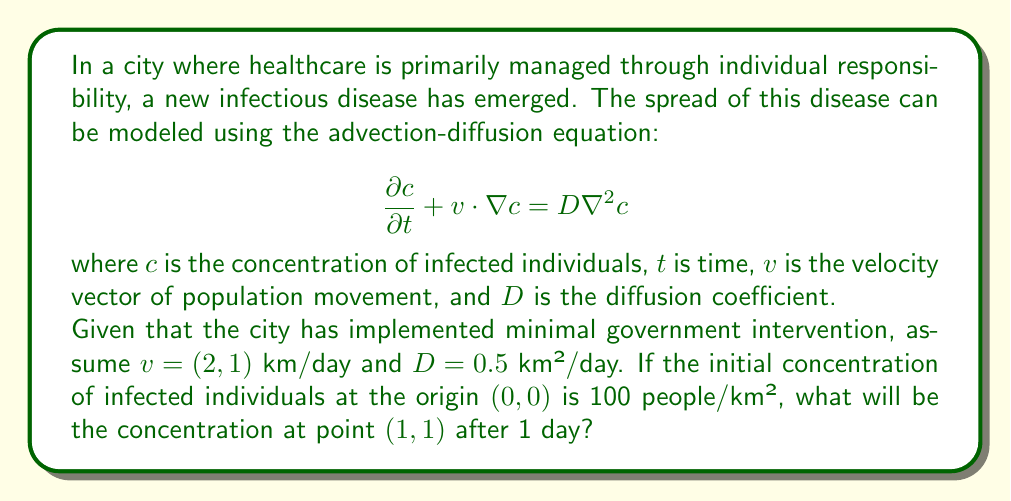Show me your answer to this math problem. To solve this problem, we need to use the fundamental solution of the advection-diffusion equation in two dimensions. The solution for a point source at the origin is given by:

$$c(x, y, t) = \frac{M}{4\pi Dt} \exp\left(-\frac{(x-v_xt)^2 + (y-v_yt)^2}{4Dt}\right)$$

Where:
- $M$ is the initial total number of infected individuals (point source strength)
- $(x, y)$ is the position where we want to calculate the concentration
- $t$ is the time elapsed
- $(v_x, v_y)$ are the components of the velocity vector
- $D$ is the diffusion coefficient

Steps to solve:

1) First, we need to calculate $M$. Since the initial concentration is 100 people/km² at the origin, we can assume this is over a small area (e.g., 1 km²). So, $M = 100$ people.

2) We're asked to find the concentration at $(1, 1)$ after 1 day, so $x = 1$, $y = 1$, and $t = 1$.

3) We're given $v = (2, 1)$, so $v_x = 2$ and $v_y = 1$.

4) $D = 0.5$ km²/day.

5) Now, let's substitute these values into the equation:

$$c(1, 1, 1) = \frac{100}{4\pi(0.5)(1)} \exp\left(-\frac{(1-2(1))^2 + (1-1(1))^2}{4(0.5)(1)}\right)$$

6) Simplify:

$$c(1, 1, 1) = \frac{100}{2\pi} \exp\left(-\frac{(-1)^2 + (0)^2}{2}\right)$$

7) Calculate:

$$c(1, 1, 1) = \frac{100}{2\pi} \exp\left(-\frac{1}{2}\right) \approx 9.58$$

Therefore, the concentration at point $(1, 1)$ after 1 day will be approximately 9.58 people/km².
Answer: 9.58 people/km² 